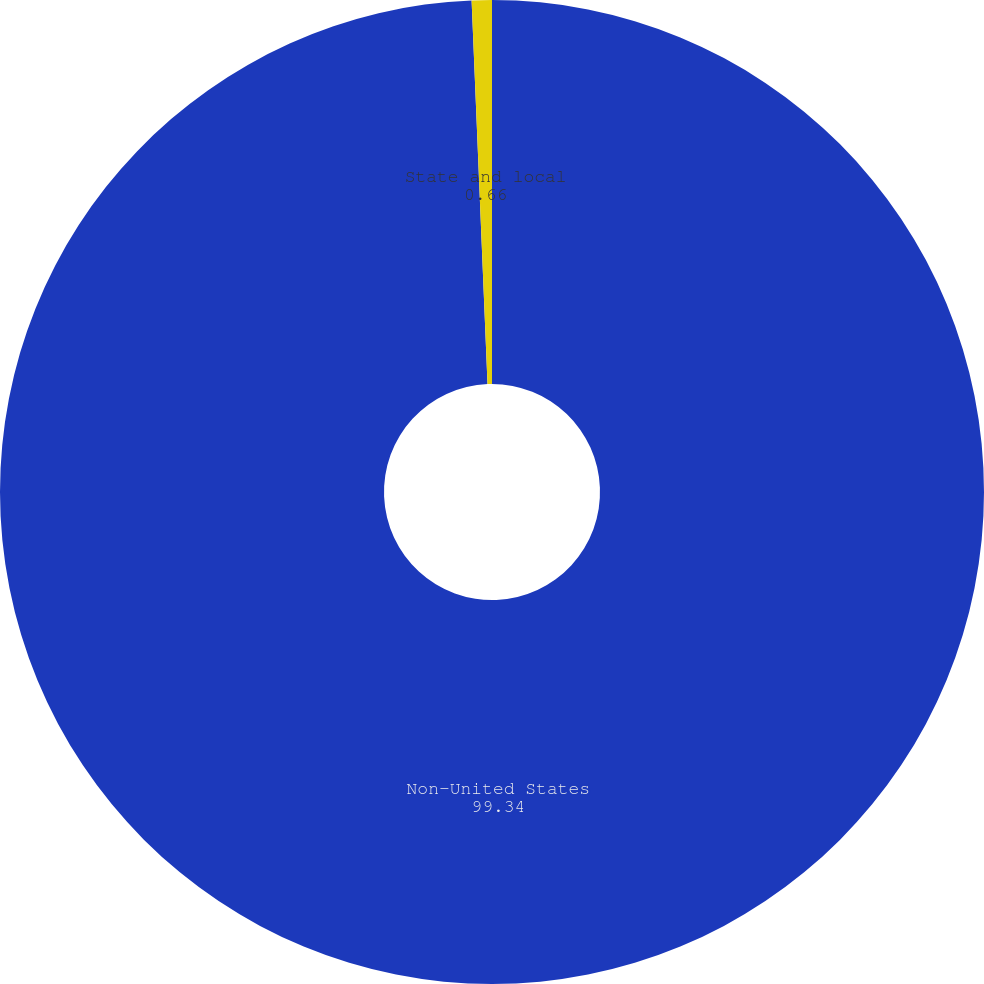Convert chart. <chart><loc_0><loc_0><loc_500><loc_500><pie_chart><fcel>Non-United States<fcel>State and local<nl><fcel>99.34%<fcel>0.66%<nl></chart> 